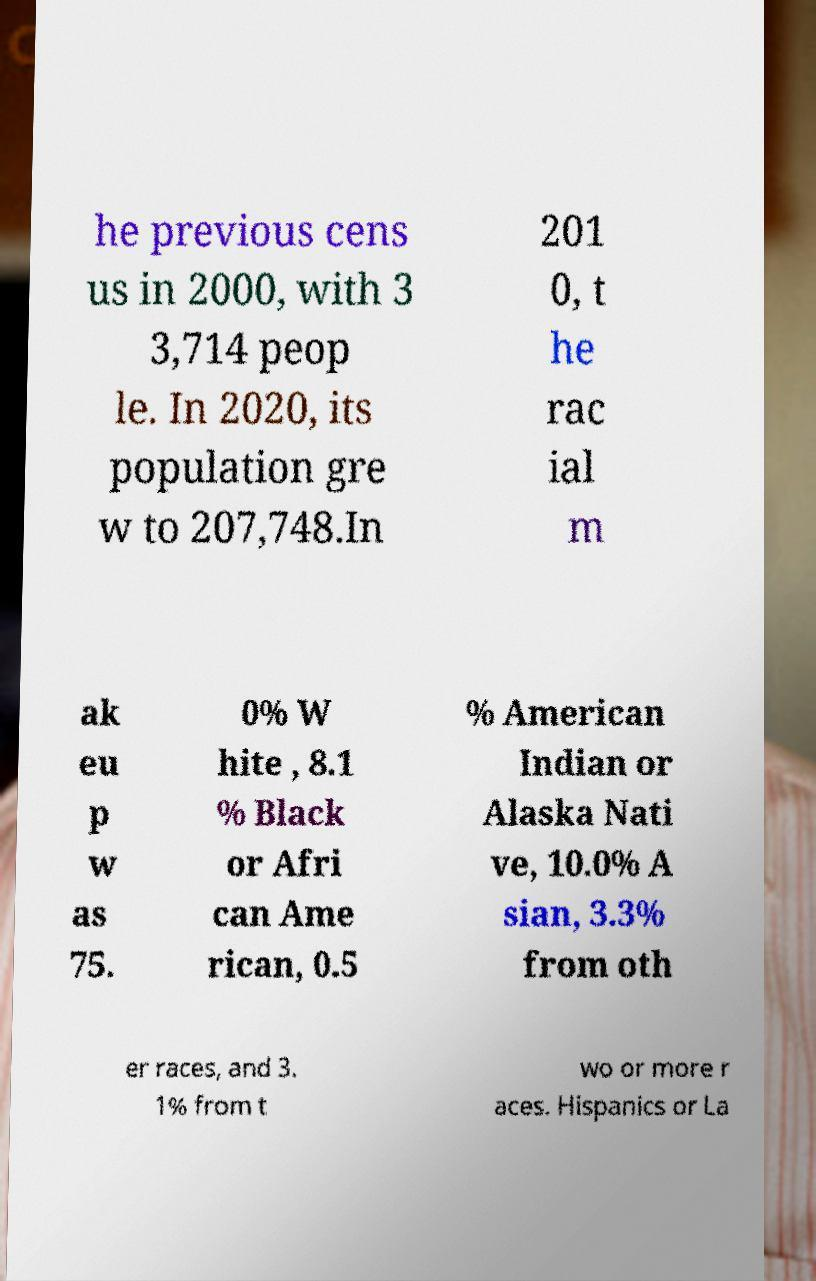Can you read and provide the text displayed in the image?This photo seems to have some interesting text. Can you extract and type it out for me? he previous cens us in 2000, with 3 3,714 peop le. In 2020, its population gre w to 207,748.In 201 0, t he rac ial m ak eu p w as 75. 0% W hite , 8.1 % Black or Afri can Ame rican, 0.5 % American Indian or Alaska Nati ve, 10.0% A sian, 3.3% from oth er races, and 3. 1% from t wo or more r aces. Hispanics or La 